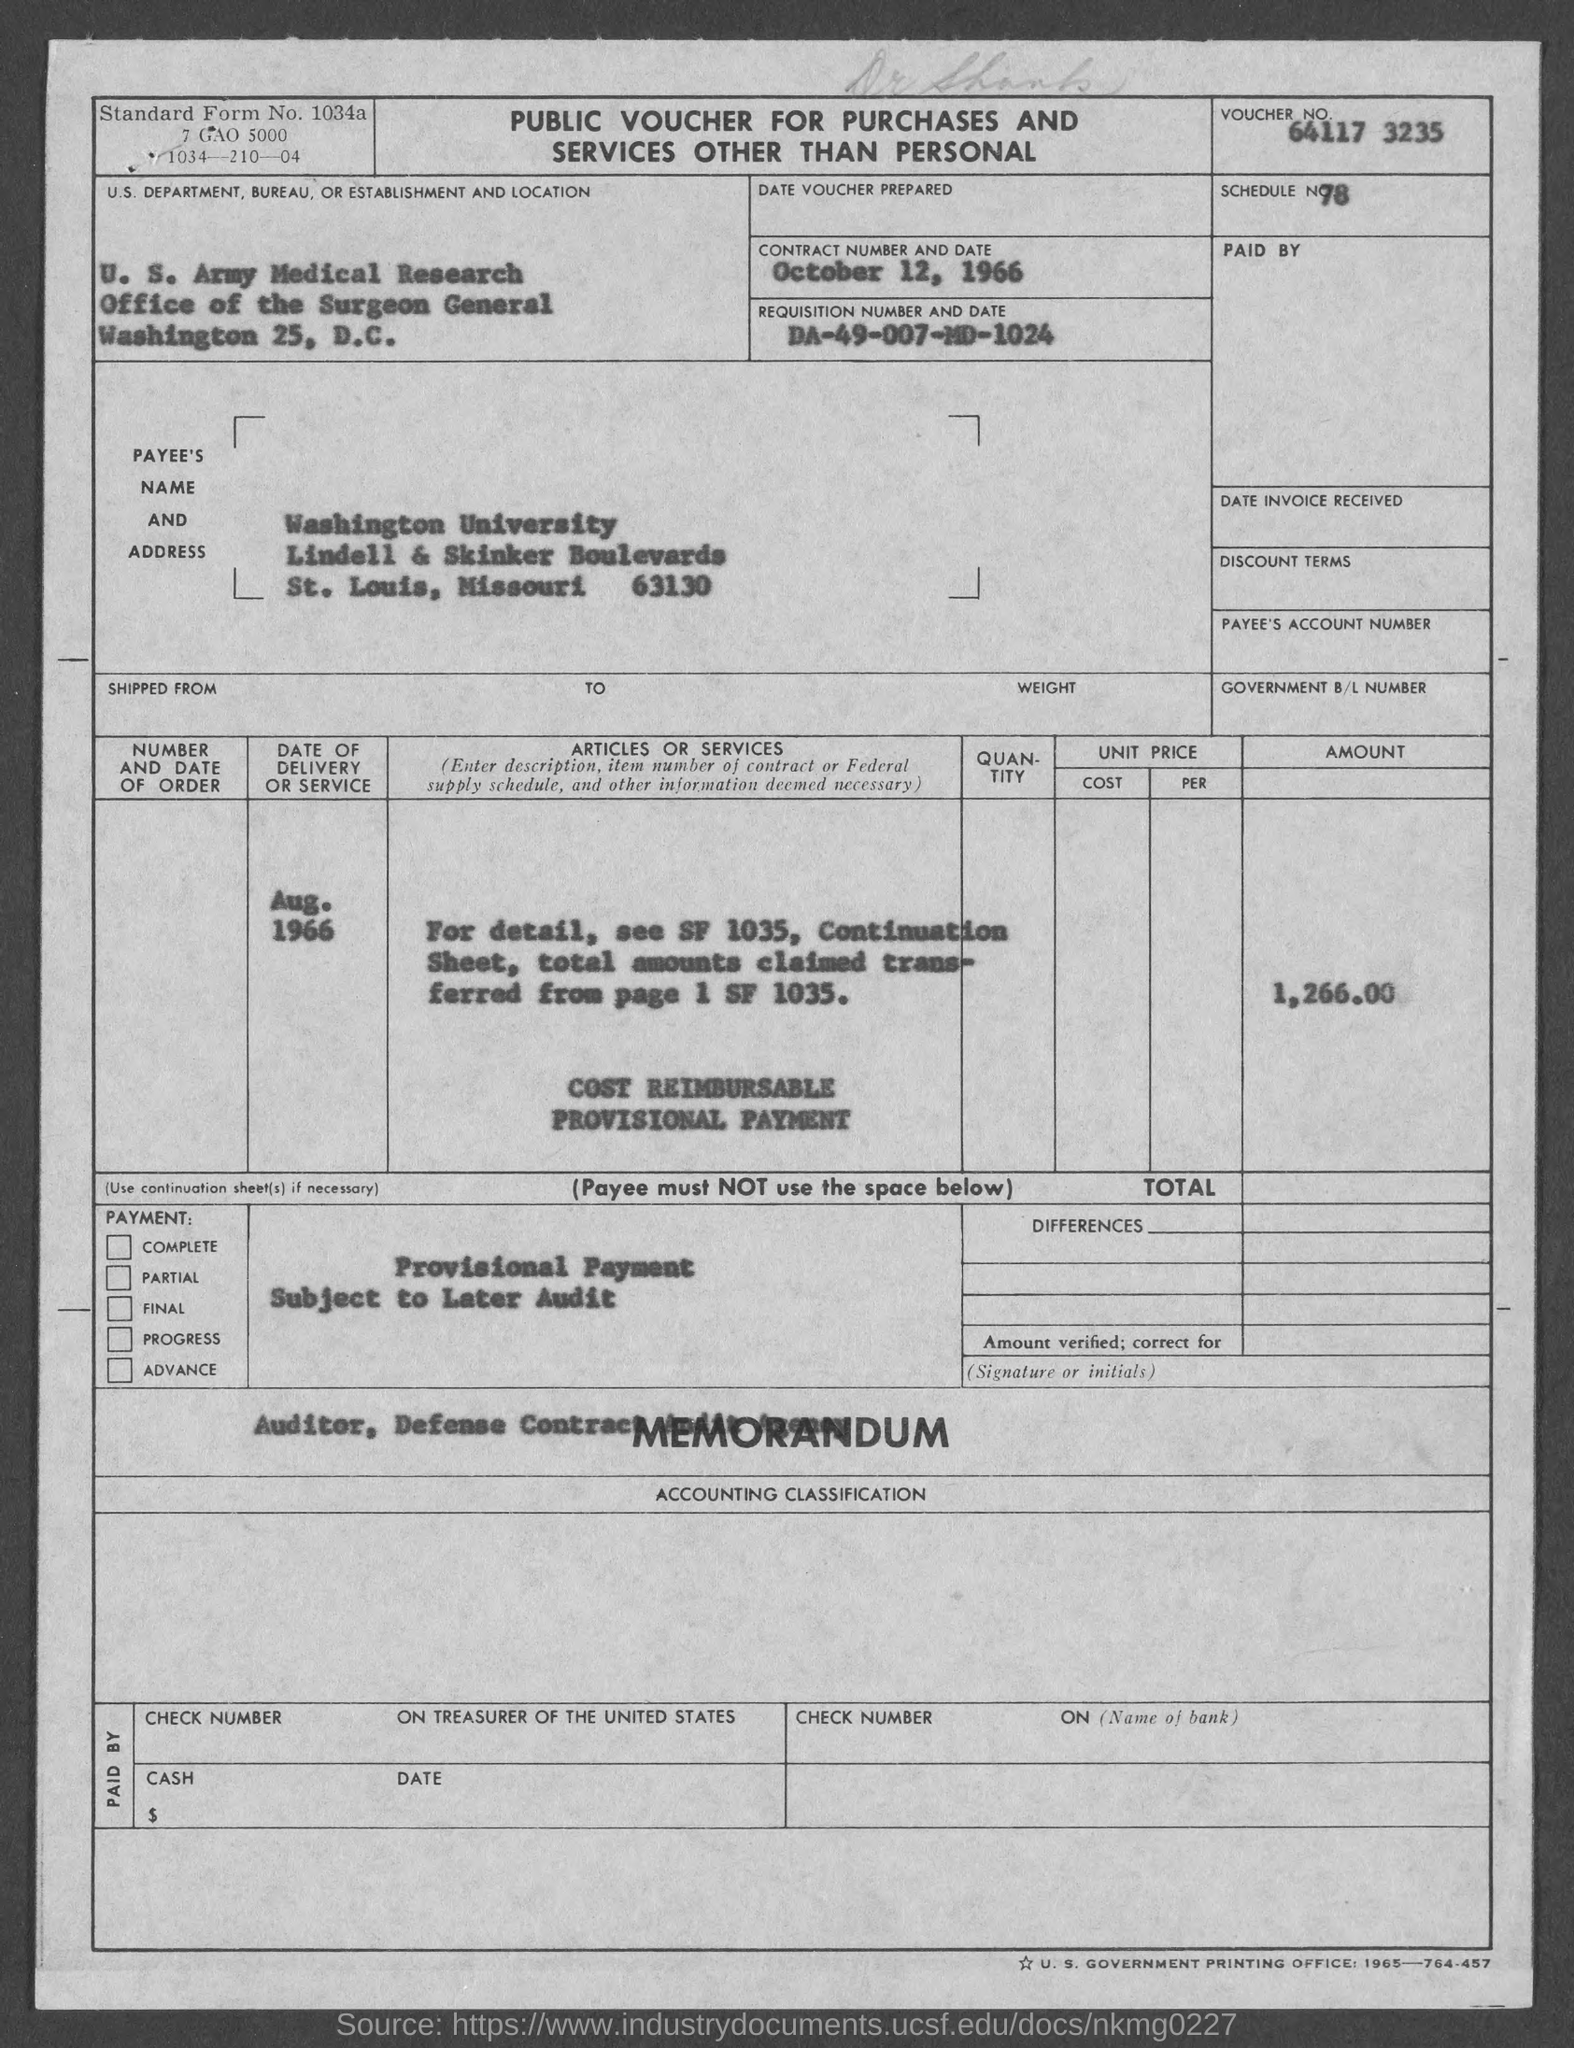What is the voucher no.?
Provide a short and direct response. 64117 3235. What is the schedule no.?
Offer a terse response. 78. In which state is washington university at?
Provide a short and direct response. Missouri. What is the standard form no.?
Give a very brief answer. 1034a. What is the requisition number ?
Your answer should be compact. DA-49-007-MD-1024. 